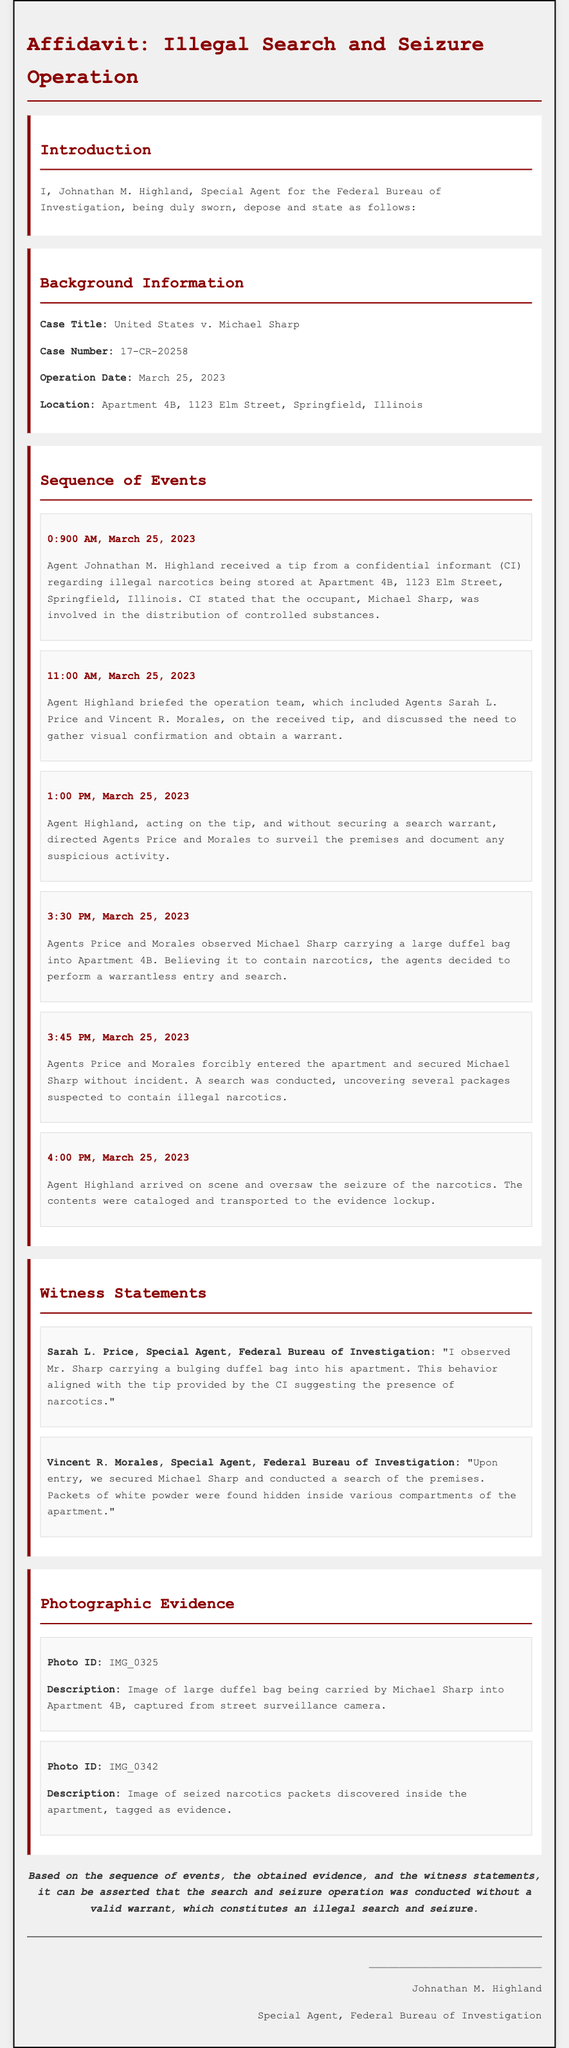What is the case title? The case title is specified in the document under Background Information, which indicates the formal name of the case.
Answer: United States v. Michael Sharp Who is the affiant? The affiant is the person providing the sworn statement in the affidavit, which is critical for establishing the validity of the testimony.
Answer: Johnathan M. Highland What time did the operation begin? The operation date and time are noted in the Background Information section, which provides the specific start time for the events discussed.
Answer: 0:900 AM What did Agents Price and Morales observe at 3:30 PM? The observation made by the agents is mentioned in the Sequence of Events, detailing the key moment leading to the search and seizure.
Answer: Michael Sharp carrying a large duffel bag Was a search warrant secured before the entry? The document explicitly states the circumstances surrounding the entry, crucial for evaluating the legality of the operation.
Answer: No What location is listed for the operation? The operation location is mentioned in the Background Information, identifying where the search and seizure took place.
Answer: Apartment 4B, 1123 Elm Street, Springfield, Illinois What was contained in the duffel bag observed by Agent Price? The document hints at the contents of the duffel bag as part of the agents' observations leading to their actions.
Answer: Narcotics Who provided the tip about illegal activities? The informant's role in the case is important for establishing the basis of the agents' actions.
Answer: Confidential informant What time did Agent Highland arrive on the scene? Agent Highland's arrival is noted in the Sequence of Events and is relevant to the overall timeline of the operation.
Answer: 4:00 PM 